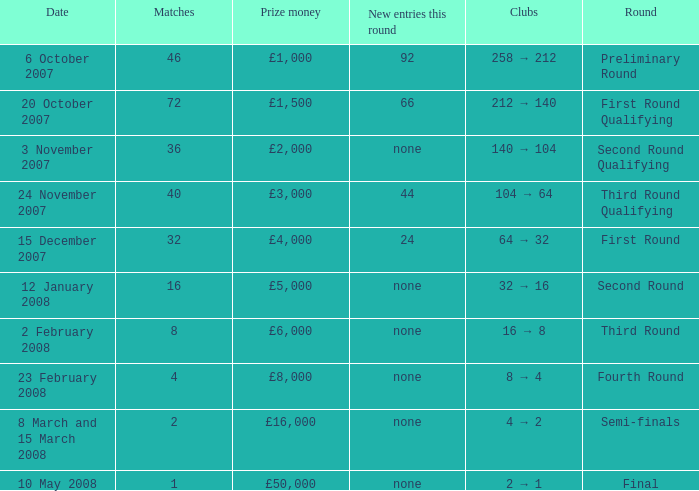How many new entries this round have clubs 2 → 1? None. 